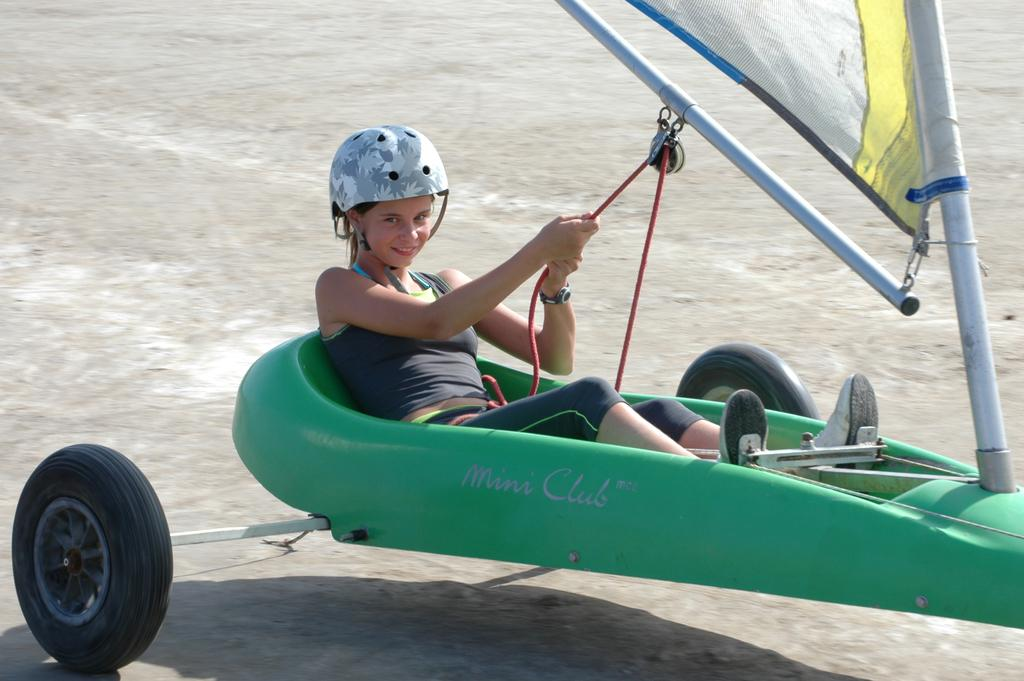Who or what is the main subject in the image? There is a person in the image. What is the person doing in the image? The person is on the land sailing. What type of surface can be seen at the bottom of the image? There is a road at the bottom of the image. What type of stem can be seen growing from the person's head in the image? There is no stem growing from the person's head in the image. How steep is the slope in the image? There is no slope present in the image; it features a person land sailing on a flat surface. 